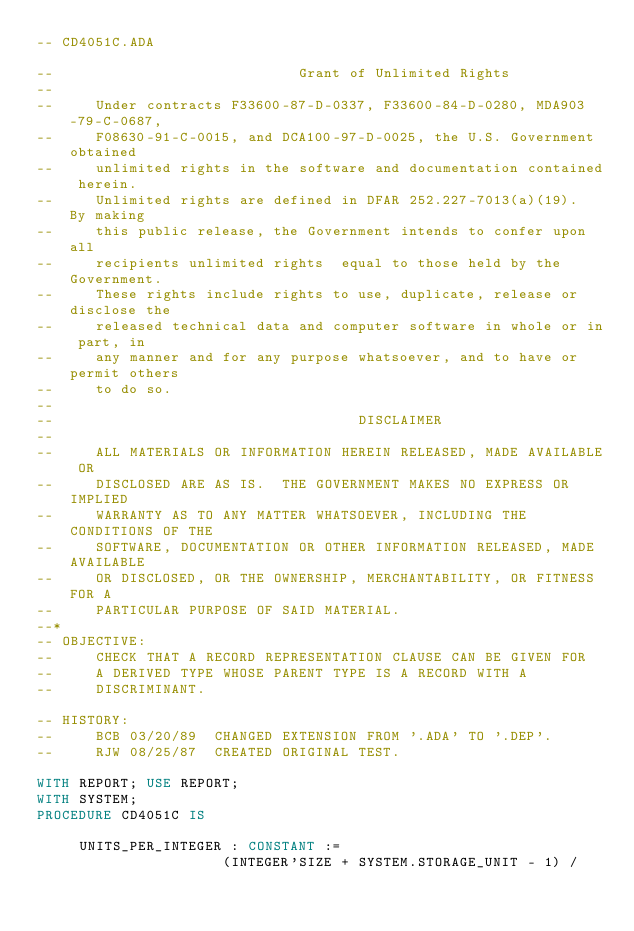Convert code to text. <code><loc_0><loc_0><loc_500><loc_500><_Ada_>-- CD4051C.ADA

--                             Grant of Unlimited Rights
--
--     Under contracts F33600-87-D-0337, F33600-84-D-0280, MDA903-79-C-0687,
--     F08630-91-C-0015, and DCA100-97-D-0025, the U.S. Government obtained 
--     unlimited rights in the software and documentation contained herein.
--     Unlimited rights are defined in DFAR 252.227-7013(a)(19).  By making 
--     this public release, the Government intends to confer upon all 
--     recipients unlimited rights  equal to those held by the Government.  
--     These rights include rights to use, duplicate, release or disclose the 
--     released technical data and computer software in whole or in part, in 
--     any manner and for any purpose whatsoever, and to have or permit others 
--     to do so.
--
--                                    DISCLAIMER
--
--     ALL MATERIALS OR INFORMATION HEREIN RELEASED, MADE AVAILABLE OR
--     DISCLOSED ARE AS IS.  THE GOVERNMENT MAKES NO EXPRESS OR IMPLIED 
--     WARRANTY AS TO ANY MATTER WHATSOEVER, INCLUDING THE CONDITIONS OF THE
--     SOFTWARE, DOCUMENTATION OR OTHER INFORMATION RELEASED, MADE AVAILABLE 
--     OR DISCLOSED, OR THE OWNERSHIP, MERCHANTABILITY, OR FITNESS FOR A
--     PARTICULAR PURPOSE OF SAID MATERIAL.
--*
-- OBJECTIVE:
--     CHECK THAT A RECORD REPRESENTATION CLAUSE CAN BE GIVEN FOR
--     A DERIVED TYPE WHOSE PARENT TYPE IS A RECORD WITH A
--     DISCRIMINANT.

-- HISTORY:
--     BCB 03/20/89  CHANGED EXTENSION FROM '.ADA' TO '.DEP'.
--     RJW 08/25/87  CREATED ORIGINAL TEST.

WITH REPORT; USE REPORT;
WITH SYSTEM;
PROCEDURE CD4051C IS

     UNITS_PER_INTEGER : CONSTANT :=
                      (INTEGER'SIZE + SYSTEM.STORAGE_UNIT - 1) /</code> 